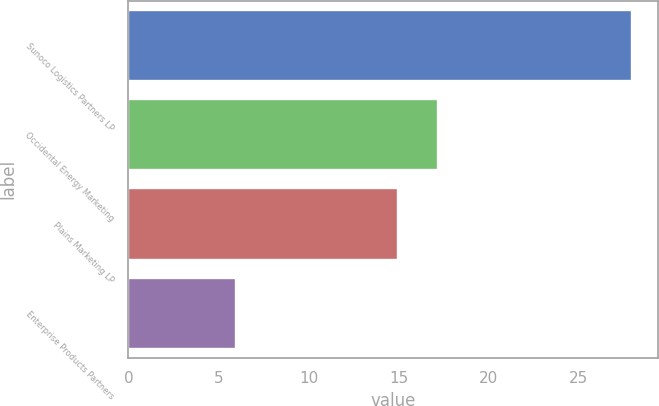Convert chart to OTSL. <chart><loc_0><loc_0><loc_500><loc_500><bar_chart><fcel>Sunoco Logistics Partners LP<fcel>Occidental Energy Marketing<fcel>Plains Marketing LP<fcel>Enterprise Products Partners<nl><fcel>28<fcel>17.2<fcel>15<fcel>6<nl></chart> 